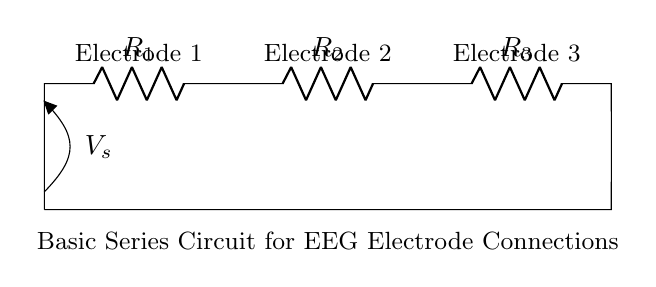What are the components of this circuit? The circuit consists of three resistors and a voltage source. The resistors are labeled R1, R2, and R3, and the voltage source is labeled V_s.
Answer: resistors and a voltage source What is the total number of electrodes in this circuit? The circuit diagram indicates three electrodes, which are marked above R1, R2, and R3.
Answer: three What type of circuit is displayed? The diagram represents a series circuit, where components are connected end-to-end, and the current has only one path to follow.
Answer: series circuit How many resistors are in this circuit? The visual indicates there are three resistors in the series configuration, labeled R1, R2, and R3.
Answer: three What is the role of the voltage source? The voltage source V_s provides the electrical energy needed to drive the current through the circuit and across the electrodes and resistors.
Answer: to provide electrical energy How does current flow in this circuit? In a series circuit like this, the current flows through each resistor one after the other, maintaining the same current level throughout all components.
Answer: in one path through all components What would happen if one resistor failed? In a series configuration, if one resistor fails (becomes open), the entire circuit would break, stopping the current flow through all components.
Answer: the circuit would stop working 